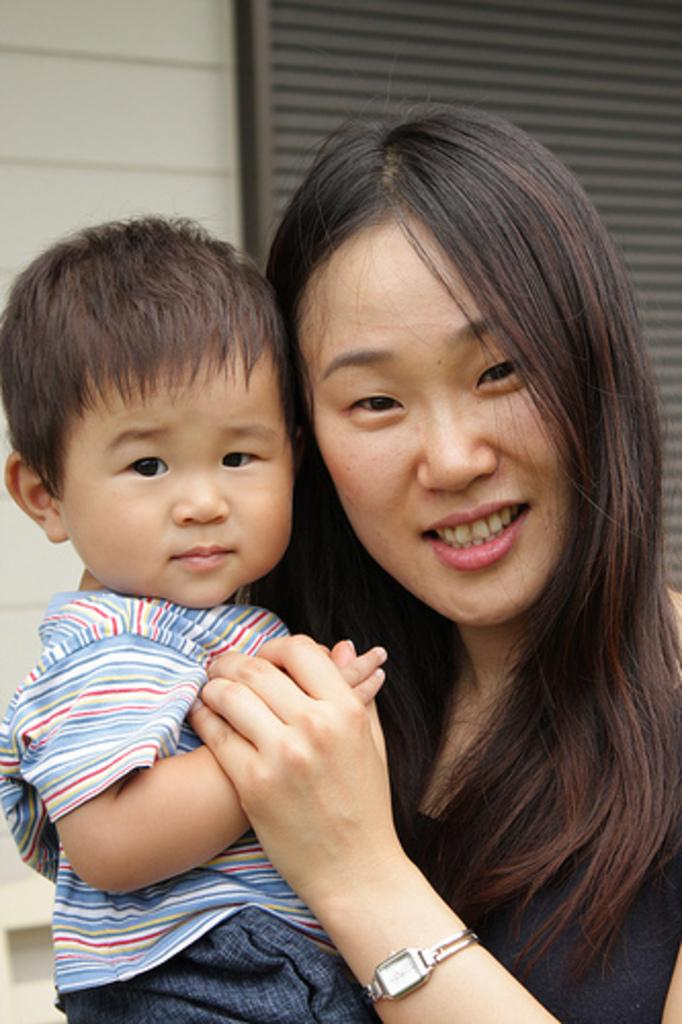How many people are in the image? There are two people in the image. What can be observed about the clothing of the people in the image? The people are wearing different color dresses. What colors are used in the background of the image? The background of the image is cream and black in color. Can you see any wounds on the people in the image? There is no indication of any wounds on the people in the image. How do the people in the image maintain their balance? The image does not show the people in motion or in a situation where balance would be relevant. 